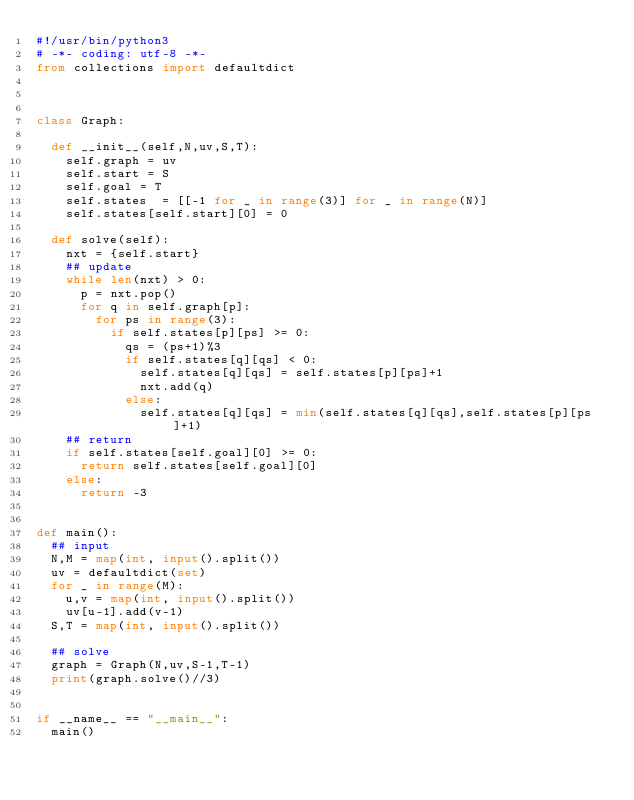<code> <loc_0><loc_0><loc_500><loc_500><_Python_>#!/usr/bin/python3
# -*- coding: utf-8 -*-
from collections import defaultdict



class Graph:

  def __init__(self,N,uv,S,T):
    self.graph = uv
    self.start = S
    self.goal = T
    self.states  = [[-1 for _ in range(3)] for _ in range(N)]
    self.states[self.start][0] = 0

  def solve(self):
    nxt = {self.start}
    ## update
    while len(nxt) > 0:
      p = nxt.pop()
      for q in self.graph[p]:
        for ps in range(3):
          if self.states[p][ps] >= 0:
            qs = (ps+1)%3
            if self.states[q][qs] < 0:
              self.states[q][qs] = self.states[p][ps]+1
              nxt.add(q)
            else:
              self.states[q][qs] = min(self.states[q][qs],self.states[p][ps]+1)
    ## return
    if self.states[self.goal][0] >= 0:
      return self.states[self.goal][0]
    else:
      return -3


def main():
  ## input
  N,M = map(int, input().split())
  uv = defaultdict(set)
  for _ in range(M):
    u,v = map(int, input().split())
    uv[u-1].add(v-1)
  S,T = map(int, input().split())

  ## solve
  graph = Graph(N,uv,S-1,T-1)
  print(graph.solve()//3)


if __name__ == "__main__":
  main()</code> 